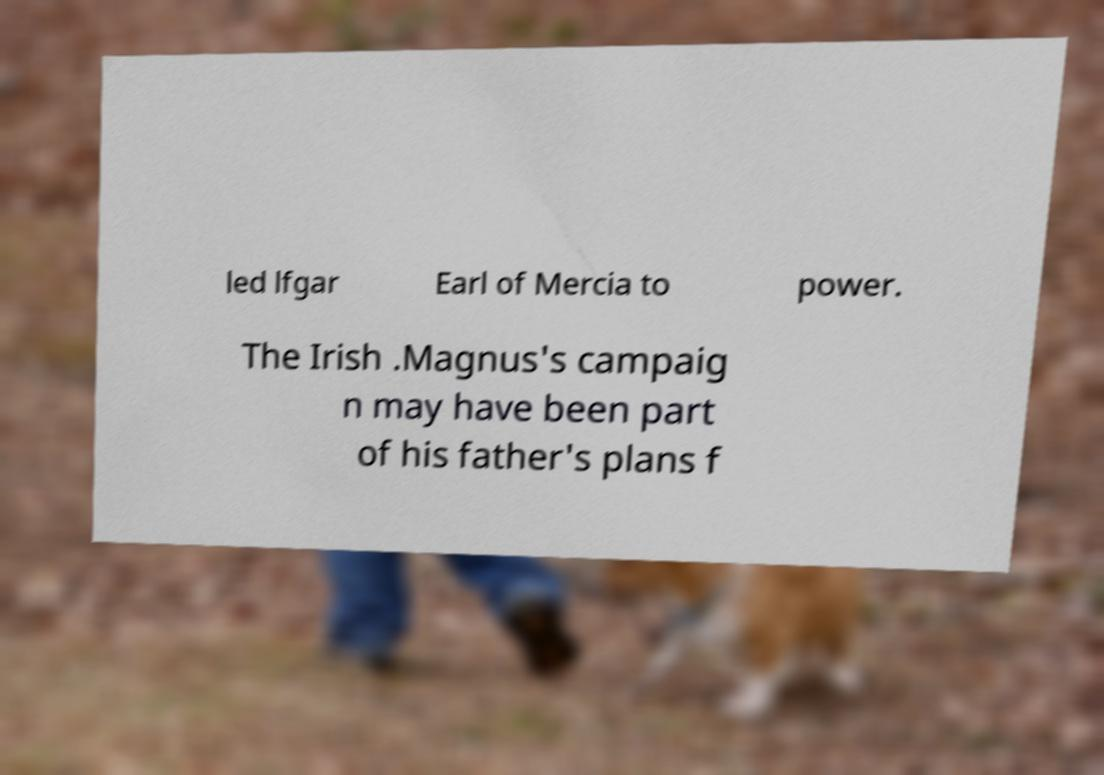Could you assist in decoding the text presented in this image and type it out clearly? led lfgar Earl of Mercia to power. The Irish .Magnus's campaig n may have been part of his father's plans f 